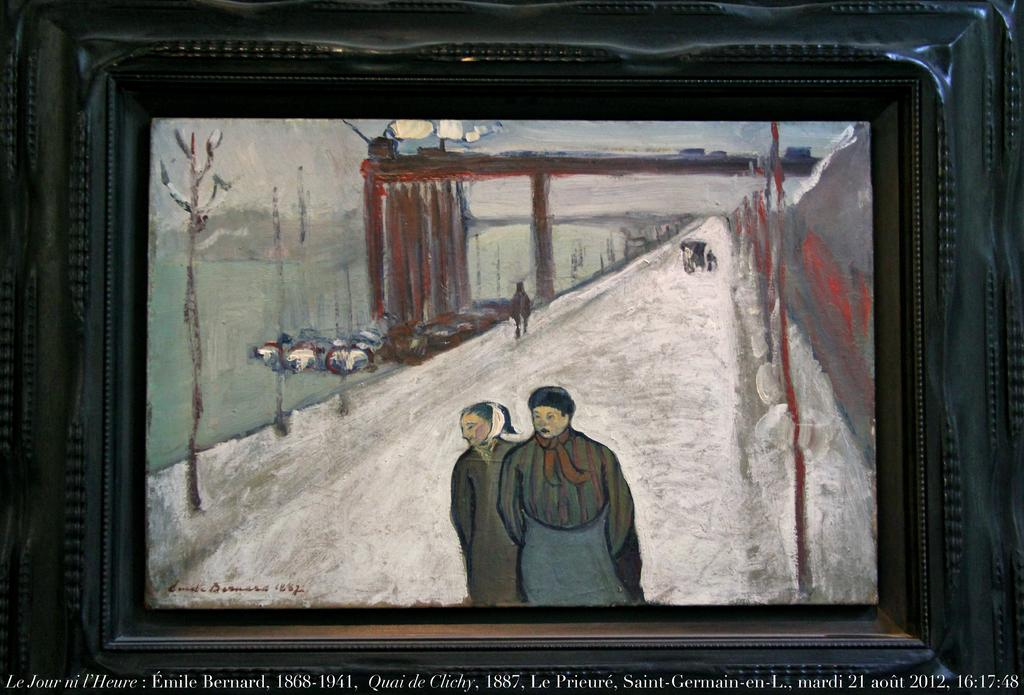<image>
Render a clear and concise summary of the photo. A painting with a caption under it that says it was from 1887. 